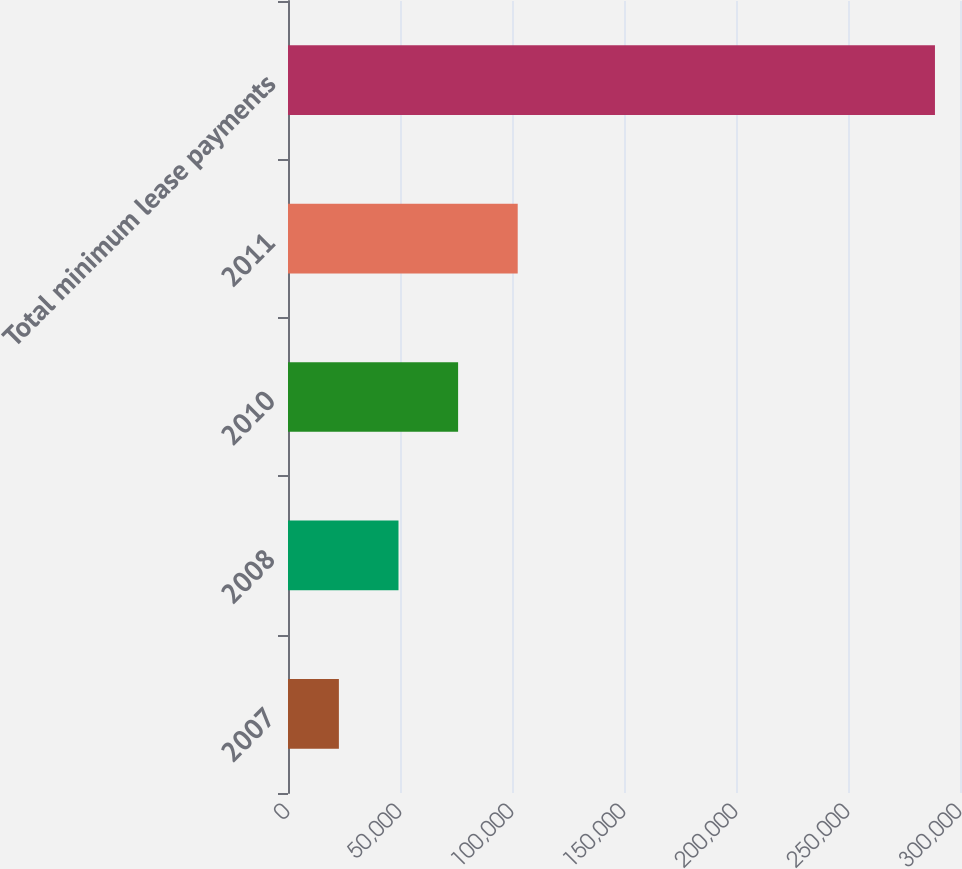<chart> <loc_0><loc_0><loc_500><loc_500><bar_chart><fcel>2007<fcel>2008<fcel>2010<fcel>2011<fcel>Total minimum lease payments<nl><fcel>22718<fcel>49328.5<fcel>75939<fcel>102550<fcel>288823<nl></chart> 